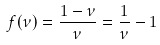<formula> <loc_0><loc_0><loc_500><loc_500>f ( \nu ) = \frac { 1 - \nu } { \nu } = \frac { 1 } { \nu } - 1</formula> 